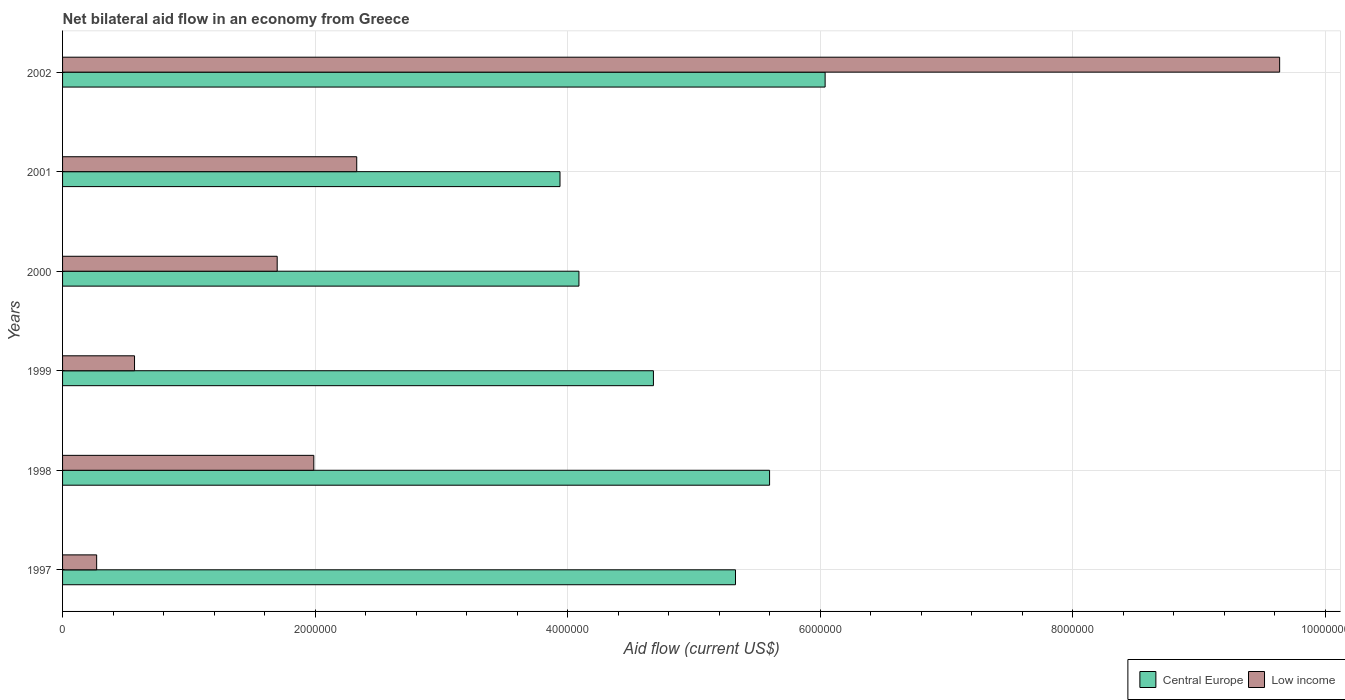How many different coloured bars are there?
Your answer should be very brief. 2. How many groups of bars are there?
Give a very brief answer. 6. Are the number of bars per tick equal to the number of legend labels?
Ensure brevity in your answer.  Yes. Are the number of bars on each tick of the Y-axis equal?
Give a very brief answer. Yes. How many bars are there on the 2nd tick from the top?
Give a very brief answer. 2. What is the label of the 5th group of bars from the top?
Provide a succinct answer. 1998. In how many cases, is the number of bars for a given year not equal to the number of legend labels?
Make the answer very short. 0. What is the net bilateral aid flow in Low income in 2002?
Your answer should be compact. 9.64e+06. Across all years, what is the maximum net bilateral aid flow in Low income?
Your answer should be very brief. 9.64e+06. Across all years, what is the minimum net bilateral aid flow in Central Europe?
Your response must be concise. 3.94e+06. What is the total net bilateral aid flow in Low income in the graph?
Your answer should be compact. 1.65e+07. What is the difference between the net bilateral aid flow in Central Europe in 1998 and that in 2000?
Your response must be concise. 1.51e+06. What is the difference between the net bilateral aid flow in Central Europe in 2000 and the net bilateral aid flow in Low income in 1997?
Your answer should be compact. 3.82e+06. What is the average net bilateral aid flow in Central Europe per year?
Provide a short and direct response. 4.95e+06. In the year 2000, what is the difference between the net bilateral aid flow in Central Europe and net bilateral aid flow in Low income?
Your answer should be very brief. 2.39e+06. In how many years, is the net bilateral aid flow in Central Europe greater than 2800000 US$?
Keep it short and to the point. 6. What is the ratio of the net bilateral aid flow in Central Europe in 2000 to that in 2002?
Provide a short and direct response. 0.68. Is the net bilateral aid flow in Low income in 1998 less than that in 2002?
Make the answer very short. Yes. What is the difference between the highest and the second highest net bilateral aid flow in Low income?
Your answer should be compact. 7.31e+06. What is the difference between the highest and the lowest net bilateral aid flow in Low income?
Your answer should be very brief. 9.37e+06. In how many years, is the net bilateral aid flow in Central Europe greater than the average net bilateral aid flow in Central Europe taken over all years?
Make the answer very short. 3. What does the 1st bar from the top in 2001 represents?
Provide a short and direct response. Low income. How many bars are there?
Give a very brief answer. 12. What is the difference between two consecutive major ticks on the X-axis?
Your answer should be compact. 2.00e+06. Are the values on the major ticks of X-axis written in scientific E-notation?
Offer a very short reply. No. Does the graph contain any zero values?
Provide a succinct answer. No. Does the graph contain grids?
Give a very brief answer. Yes. How many legend labels are there?
Offer a very short reply. 2. How are the legend labels stacked?
Make the answer very short. Horizontal. What is the title of the graph?
Make the answer very short. Net bilateral aid flow in an economy from Greece. Does "Bhutan" appear as one of the legend labels in the graph?
Make the answer very short. No. What is the Aid flow (current US$) of Central Europe in 1997?
Provide a short and direct response. 5.33e+06. What is the Aid flow (current US$) in Low income in 1997?
Keep it short and to the point. 2.70e+05. What is the Aid flow (current US$) in Central Europe in 1998?
Provide a short and direct response. 5.60e+06. What is the Aid flow (current US$) of Low income in 1998?
Make the answer very short. 1.99e+06. What is the Aid flow (current US$) of Central Europe in 1999?
Keep it short and to the point. 4.68e+06. What is the Aid flow (current US$) in Low income in 1999?
Offer a terse response. 5.70e+05. What is the Aid flow (current US$) of Central Europe in 2000?
Make the answer very short. 4.09e+06. What is the Aid flow (current US$) in Low income in 2000?
Your answer should be very brief. 1.70e+06. What is the Aid flow (current US$) in Central Europe in 2001?
Your answer should be compact. 3.94e+06. What is the Aid flow (current US$) of Low income in 2001?
Offer a very short reply. 2.33e+06. What is the Aid flow (current US$) of Central Europe in 2002?
Provide a succinct answer. 6.04e+06. What is the Aid flow (current US$) in Low income in 2002?
Offer a terse response. 9.64e+06. Across all years, what is the maximum Aid flow (current US$) of Central Europe?
Keep it short and to the point. 6.04e+06. Across all years, what is the maximum Aid flow (current US$) in Low income?
Ensure brevity in your answer.  9.64e+06. Across all years, what is the minimum Aid flow (current US$) of Central Europe?
Keep it short and to the point. 3.94e+06. What is the total Aid flow (current US$) of Central Europe in the graph?
Provide a succinct answer. 2.97e+07. What is the total Aid flow (current US$) of Low income in the graph?
Your answer should be compact. 1.65e+07. What is the difference between the Aid flow (current US$) in Central Europe in 1997 and that in 1998?
Provide a short and direct response. -2.70e+05. What is the difference between the Aid flow (current US$) in Low income in 1997 and that in 1998?
Your answer should be compact. -1.72e+06. What is the difference between the Aid flow (current US$) of Central Europe in 1997 and that in 1999?
Give a very brief answer. 6.50e+05. What is the difference between the Aid flow (current US$) of Low income in 1997 and that in 1999?
Make the answer very short. -3.00e+05. What is the difference between the Aid flow (current US$) of Central Europe in 1997 and that in 2000?
Ensure brevity in your answer.  1.24e+06. What is the difference between the Aid flow (current US$) in Low income in 1997 and that in 2000?
Ensure brevity in your answer.  -1.43e+06. What is the difference between the Aid flow (current US$) of Central Europe in 1997 and that in 2001?
Give a very brief answer. 1.39e+06. What is the difference between the Aid flow (current US$) of Low income in 1997 and that in 2001?
Provide a succinct answer. -2.06e+06. What is the difference between the Aid flow (current US$) in Central Europe in 1997 and that in 2002?
Keep it short and to the point. -7.10e+05. What is the difference between the Aid flow (current US$) in Low income in 1997 and that in 2002?
Give a very brief answer. -9.37e+06. What is the difference between the Aid flow (current US$) in Central Europe in 1998 and that in 1999?
Offer a terse response. 9.20e+05. What is the difference between the Aid flow (current US$) in Low income in 1998 and that in 1999?
Offer a terse response. 1.42e+06. What is the difference between the Aid flow (current US$) in Central Europe in 1998 and that in 2000?
Make the answer very short. 1.51e+06. What is the difference between the Aid flow (current US$) of Central Europe in 1998 and that in 2001?
Your response must be concise. 1.66e+06. What is the difference between the Aid flow (current US$) in Low income in 1998 and that in 2001?
Ensure brevity in your answer.  -3.40e+05. What is the difference between the Aid flow (current US$) in Central Europe in 1998 and that in 2002?
Offer a very short reply. -4.40e+05. What is the difference between the Aid flow (current US$) in Low income in 1998 and that in 2002?
Give a very brief answer. -7.65e+06. What is the difference between the Aid flow (current US$) of Central Europe in 1999 and that in 2000?
Keep it short and to the point. 5.90e+05. What is the difference between the Aid flow (current US$) in Low income in 1999 and that in 2000?
Ensure brevity in your answer.  -1.13e+06. What is the difference between the Aid flow (current US$) in Central Europe in 1999 and that in 2001?
Give a very brief answer. 7.40e+05. What is the difference between the Aid flow (current US$) of Low income in 1999 and that in 2001?
Provide a succinct answer. -1.76e+06. What is the difference between the Aid flow (current US$) of Central Europe in 1999 and that in 2002?
Offer a very short reply. -1.36e+06. What is the difference between the Aid flow (current US$) in Low income in 1999 and that in 2002?
Your response must be concise. -9.07e+06. What is the difference between the Aid flow (current US$) of Central Europe in 2000 and that in 2001?
Provide a short and direct response. 1.50e+05. What is the difference between the Aid flow (current US$) in Low income in 2000 and that in 2001?
Ensure brevity in your answer.  -6.30e+05. What is the difference between the Aid flow (current US$) in Central Europe in 2000 and that in 2002?
Your answer should be very brief. -1.95e+06. What is the difference between the Aid flow (current US$) in Low income in 2000 and that in 2002?
Ensure brevity in your answer.  -7.94e+06. What is the difference between the Aid flow (current US$) in Central Europe in 2001 and that in 2002?
Keep it short and to the point. -2.10e+06. What is the difference between the Aid flow (current US$) of Low income in 2001 and that in 2002?
Offer a very short reply. -7.31e+06. What is the difference between the Aid flow (current US$) of Central Europe in 1997 and the Aid flow (current US$) of Low income in 1998?
Your response must be concise. 3.34e+06. What is the difference between the Aid flow (current US$) of Central Europe in 1997 and the Aid flow (current US$) of Low income in 1999?
Ensure brevity in your answer.  4.76e+06. What is the difference between the Aid flow (current US$) in Central Europe in 1997 and the Aid flow (current US$) in Low income in 2000?
Your response must be concise. 3.63e+06. What is the difference between the Aid flow (current US$) of Central Europe in 1997 and the Aid flow (current US$) of Low income in 2001?
Your response must be concise. 3.00e+06. What is the difference between the Aid flow (current US$) in Central Europe in 1997 and the Aid flow (current US$) in Low income in 2002?
Provide a succinct answer. -4.31e+06. What is the difference between the Aid flow (current US$) in Central Europe in 1998 and the Aid flow (current US$) in Low income in 1999?
Provide a short and direct response. 5.03e+06. What is the difference between the Aid flow (current US$) of Central Europe in 1998 and the Aid flow (current US$) of Low income in 2000?
Offer a very short reply. 3.90e+06. What is the difference between the Aid flow (current US$) in Central Europe in 1998 and the Aid flow (current US$) in Low income in 2001?
Make the answer very short. 3.27e+06. What is the difference between the Aid flow (current US$) in Central Europe in 1998 and the Aid flow (current US$) in Low income in 2002?
Offer a terse response. -4.04e+06. What is the difference between the Aid flow (current US$) of Central Europe in 1999 and the Aid flow (current US$) of Low income in 2000?
Provide a succinct answer. 2.98e+06. What is the difference between the Aid flow (current US$) of Central Europe in 1999 and the Aid flow (current US$) of Low income in 2001?
Your answer should be very brief. 2.35e+06. What is the difference between the Aid flow (current US$) of Central Europe in 1999 and the Aid flow (current US$) of Low income in 2002?
Give a very brief answer. -4.96e+06. What is the difference between the Aid flow (current US$) in Central Europe in 2000 and the Aid flow (current US$) in Low income in 2001?
Give a very brief answer. 1.76e+06. What is the difference between the Aid flow (current US$) of Central Europe in 2000 and the Aid flow (current US$) of Low income in 2002?
Offer a terse response. -5.55e+06. What is the difference between the Aid flow (current US$) in Central Europe in 2001 and the Aid flow (current US$) in Low income in 2002?
Your response must be concise. -5.70e+06. What is the average Aid flow (current US$) in Central Europe per year?
Ensure brevity in your answer.  4.95e+06. What is the average Aid flow (current US$) of Low income per year?
Offer a terse response. 2.75e+06. In the year 1997, what is the difference between the Aid flow (current US$) of Central Europe and Aid flow (current US$) of Low income?
Offer a terse response. 5.06e+06. In the year 1998, what is the difference between the Aid flow (current US$) of Central Europe and Aid flow (current US$) of Low income?
Your answer should be very brief. 3.61e+06. In the year 1999, what is the difference between the Aid flow (current US$) in Central Europe and Aid flow (current US$) in Low income?
Ensure brevity in your answer.  4.11e+06. In the year 2000, what is the difference between the Aid flow (current US$) of Central Europe and Aid flow (current US$) of Low income?
Provide a succinct answer. 2.39e+06. In the year 2001, what is the difference between the Aid flow (current US$) of Central Europe and Aid flow (current US$) of Low income?
Provide a succinct answer. 1.61e+06. In the year 2002, what is the difference between the Aid flow (current US$) in Central Europe and Aid flow (current US$) in Low income?
Offer a terse response. -3.60e+06. What is the ratio of the Aid flow (current US$) in Central Europe in 1997 to that in 1998?
Ensure brevity in your answer.  0.95. What is the ratio of the Aid flow (current US$) in Low income in 1997 to that in 1998?
Ensure brevity in your answer.  0.14. What is the ratio of the Aid flow (current US$) of Central Europe in 1997 to that in 1999?
Your answer should be very brief. 1.14. What is the ratio of the Aid flow (current US$) of Low income in 1997 to that in 1999?
Your answer should be compact. 0.47. What is the ratio of the Aid flow (current US$) of Central Europe in 1997 to that in 2000?
Ensure brevity in your answer.  1.3. What is the ratio of the Aid flow (current US$) in Low income in 1997 to that in 2000?
Make the answer very short. 0.16. What is the ratio of the Aid flow (current US$) of Central Europe in 1997 to that in 2001?
Your answer should be very brief. 1.35. What is the ratio of the Aid flow (current US$) in Low income in 1997 to that in 2001?
Your answer should be very brief. 0.12. What is the ratio of the Aid flow (current US$) in Central Europe in 1997 to that in 2002?
Keep it short and to the point. 0.88. What is the ratio of the Aid flow (current US$) in Low income in 1997 to that in 2002?
Your answer should be compact. 0.03. What is the ratio of the Aid flow (current US$) in Central Europe in 1998 to that in 1999?
Give a very brief answer. 1.2. What is the ratio of the Aid flow (current US$) in Low income in 1998 to that in 1999?
Give a very brief answer. 3.49. What is the ratio of the Aid flow (current US$) of Central Europe in 1998 to that in 2000?
Make the answer very short. 1.37. What is the ratio of the Aid flow (current US$) of Low income in 1998 to that in 2000?
Keep it short and to the point. 1.17. What is the ratio of the Aid flow (current US$) of Central Europe in 1998 to that in 2001?
Your response must be concise. 1.42. What is the ratio of the Aid flow (current US$) of Low income in 1998 to that in 2001?
Make the answer very short. 0.85. What is the ratio of the Aid flow (current US$) of Central Europe in 1998 to that in 2002?
Your answer should be very brief. 0.93. What is the ratio of the Aid flow (current US$) of Low income in 1998 to that in 2002?
Your response must be concise. 0.21. What is the ratio of the Aid flow (current US$) in Central Europe in 1999 to that in 2000?
Give a very brief answer. 1.14. What is the ratio of the Aid flow (current US$) of Low income in 1999 to that in 2000?
Offer a terse response. 0.34. What is the ratio of the Aid flow (current US$) of Central Europe in 1999 to that in 2001?
Make the answer very short. 1.19. What is the ratio of the Aid flow (current US$) in Low income in 1999 to that in 2001?
Your response must be concise. 0.24. What is the ratio of the Aid flow (current US$) in Central Europe in 1999 to that in 2002?
Offer a very short reply. 0.77. What is the ratio of the Aid flow (current US$) in Low income in 1999 to that in 2002?
Offer a very short reply. 0.06. What is the ratio of the Aid flow (current US$) in Central Europe in 2000 to that in 2001?
Offer a very short reply. 1.04. What is the ratio of the Aid flow (current US$) of Low income in 2000 to that in 2001?
Provide a short and direct response. 0.73. What is the ratio of the Aid flow (current US$) in Central Europe in 2000 to that in 2002?
Offer a terse response. 0.68. What is the ratio of the Aid flow (current US$) in Low income in 2000 to that in 2002?
Provide a succinct answer. 0.18. What is the ratio of the Aid flow (current US$) of Central Europe in 2001 to that in 2002?
Give a very brief answer. 0.65. What is the ratio of the Aid flow (current US$) in Low income in 2001 to that in 2002?
Your answer should be compact. 0.24. What is the difference between the highest and the second highest Aid flow (current US$) in Low income?
Your response must be concise. 7.31e+06. What is the difference between the highest and the lowest Aid flow (current US$) of Central Europe?
Your answer should be very brief. 2.10e+06. What is the difference between the highest and the lowest Aid flow (current US$) in Low income?
Provide a short and direct response. 9.37e+06. 